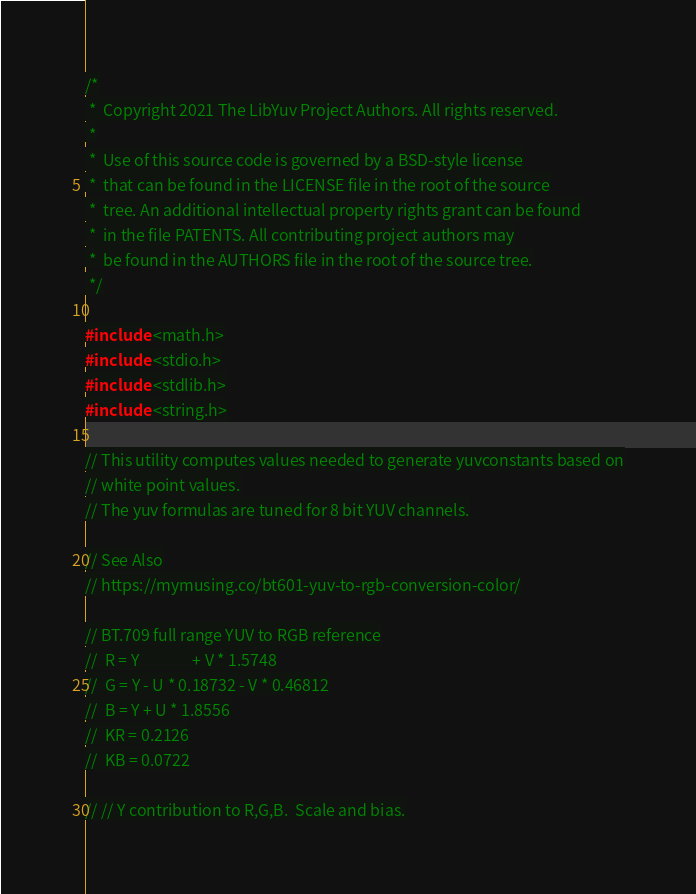Convert code to text. <code><loc_0><loc_0><loc_500><loc_500><_C_>/*
 *  Copyright 2021 The LibYuv Project Authors. All rights reserved.
 *
 *  Use of this source code is governed by a BSD-style license
 *  that can be found in the LICENSE file in the root of the source
 *  tree. An additional intellectual property rights grant can be found
 *  in the file PATENTS. All contributing project authors may
 *  be found in the AUTHORS file in the root of the source tree.
 */

#include <math.h>
#include <stdio.h>
#include <stdlib.h>
#include <string.h>

// This utility computes values needed to generate yuvconstants based on
// white point values.
// The yuv formulas are tuned for 8 bit YUV channels.

// See Also
// https://mymusing.co/bt601-yuv-to-rgb-conversion-color/

// BT.709 full range YUV to RGB reference
//  R = Y               + V * 1.5748
//  G = Y - U * 0.18732 - V * 0.46812
//  B = Y + U * 1.8556
//  KR = 0.2126
//  KB = 0.0722

// // Y contribution to R,G,B.  Scale and bias.</code> 